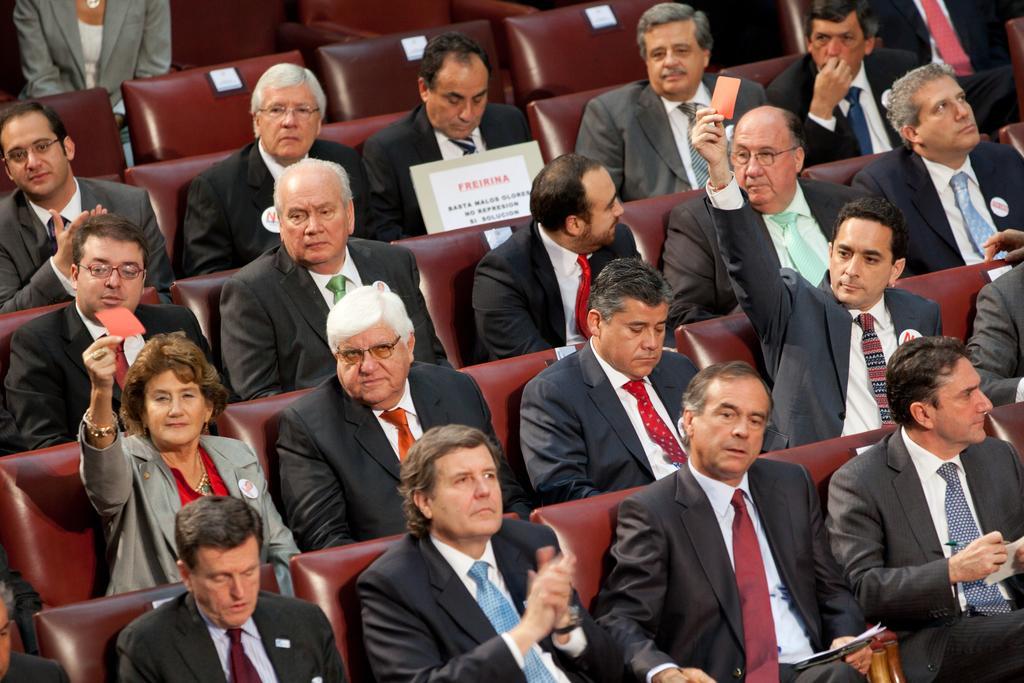Describe this image in one or two sentences. In the image we can see there are people sitting on the chair and few people are holding an orange paper slip in their hand. 